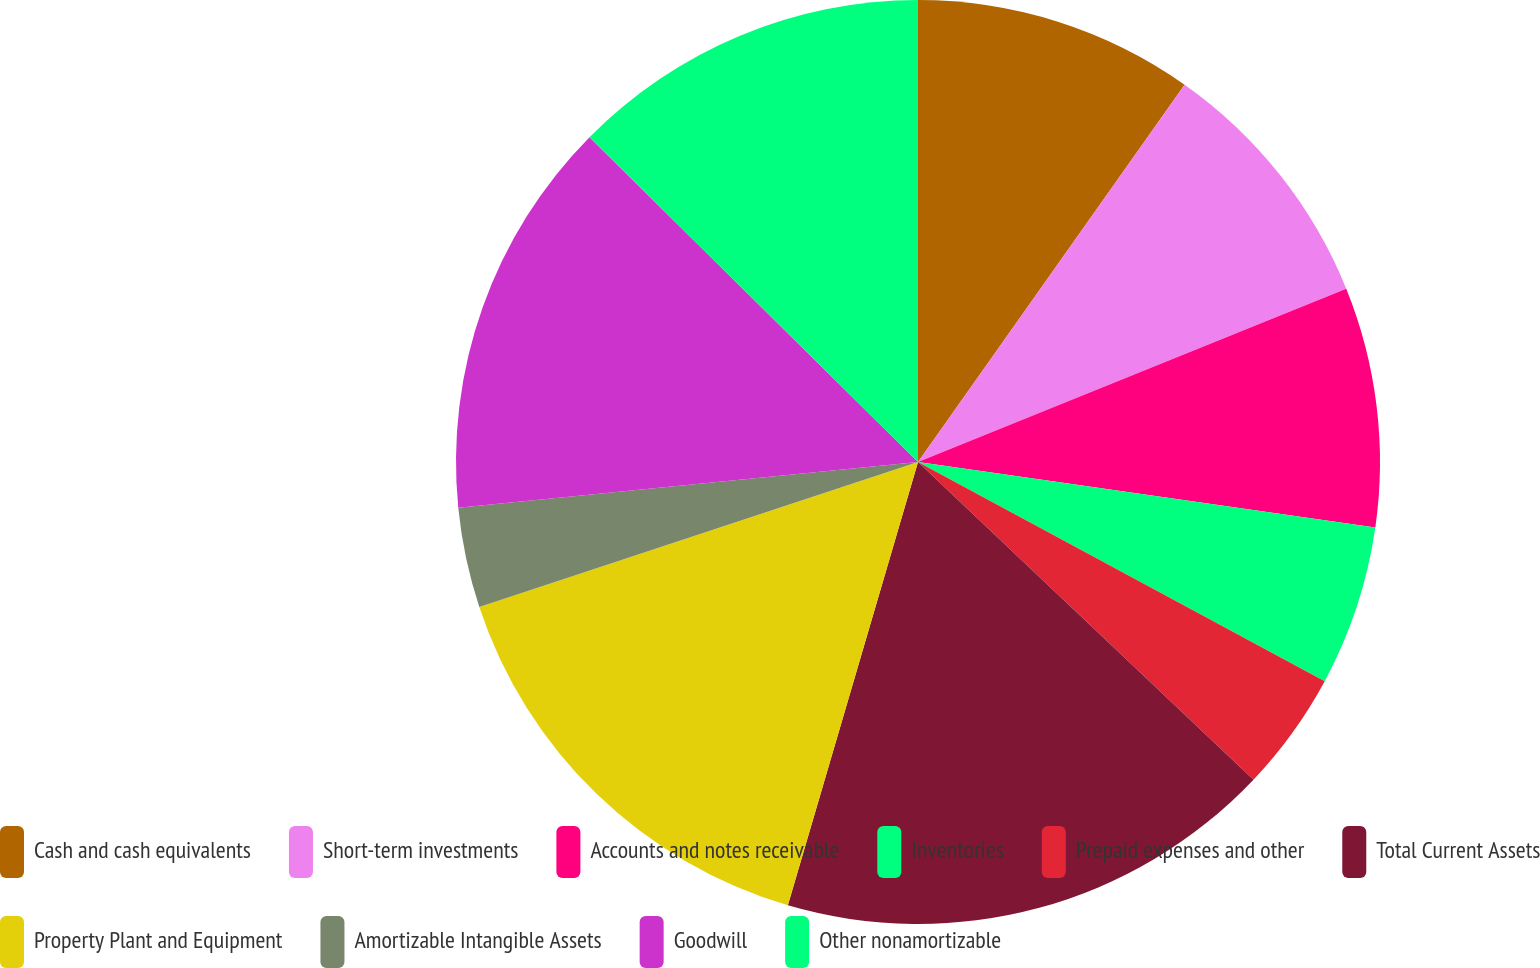Convert chart. <chart><loc_0><loc_0><loc_500><loc_500><pie_chart><fcel>Cash and cash equivalents<fcel>Short-term investments<fcel>Accounts and notes receivable<fcel>Inventories<fcel>Prepaid expenses and other<fcel>Total Current Assets<fcel>Property Plant and Equipment<fcel>Amortizable Intangible Assets<fcel>Goodwill<fcel>Other nonamortizable<nl><fcel>9.79%<fcel>9.09%<fcel>8.39%<fcel>5.6%<fcel>4.2%<fcel>17.48%<fcel>15.38%<fcel>3.5%<fcel>13.99%<fcel>12.59%<nl></chart> 